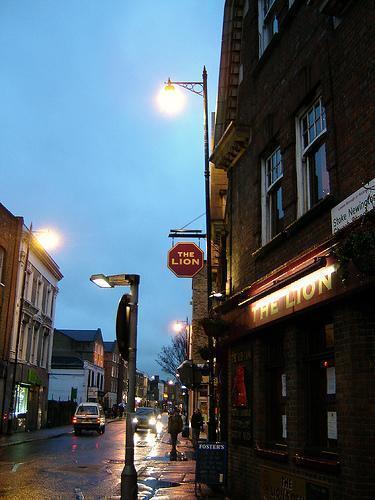Which sign will be easier for someone way down the street to spot?
Choose the correct response, then elucidate: 'Answer: answer
Rationale: rationale.'
Options: Frame, rectangle, octagon, flyers. Answer: octagon.
Rationale: The sign easier to see would be the sign for "the lion" that is shaped like a stop sign with eight sides. 